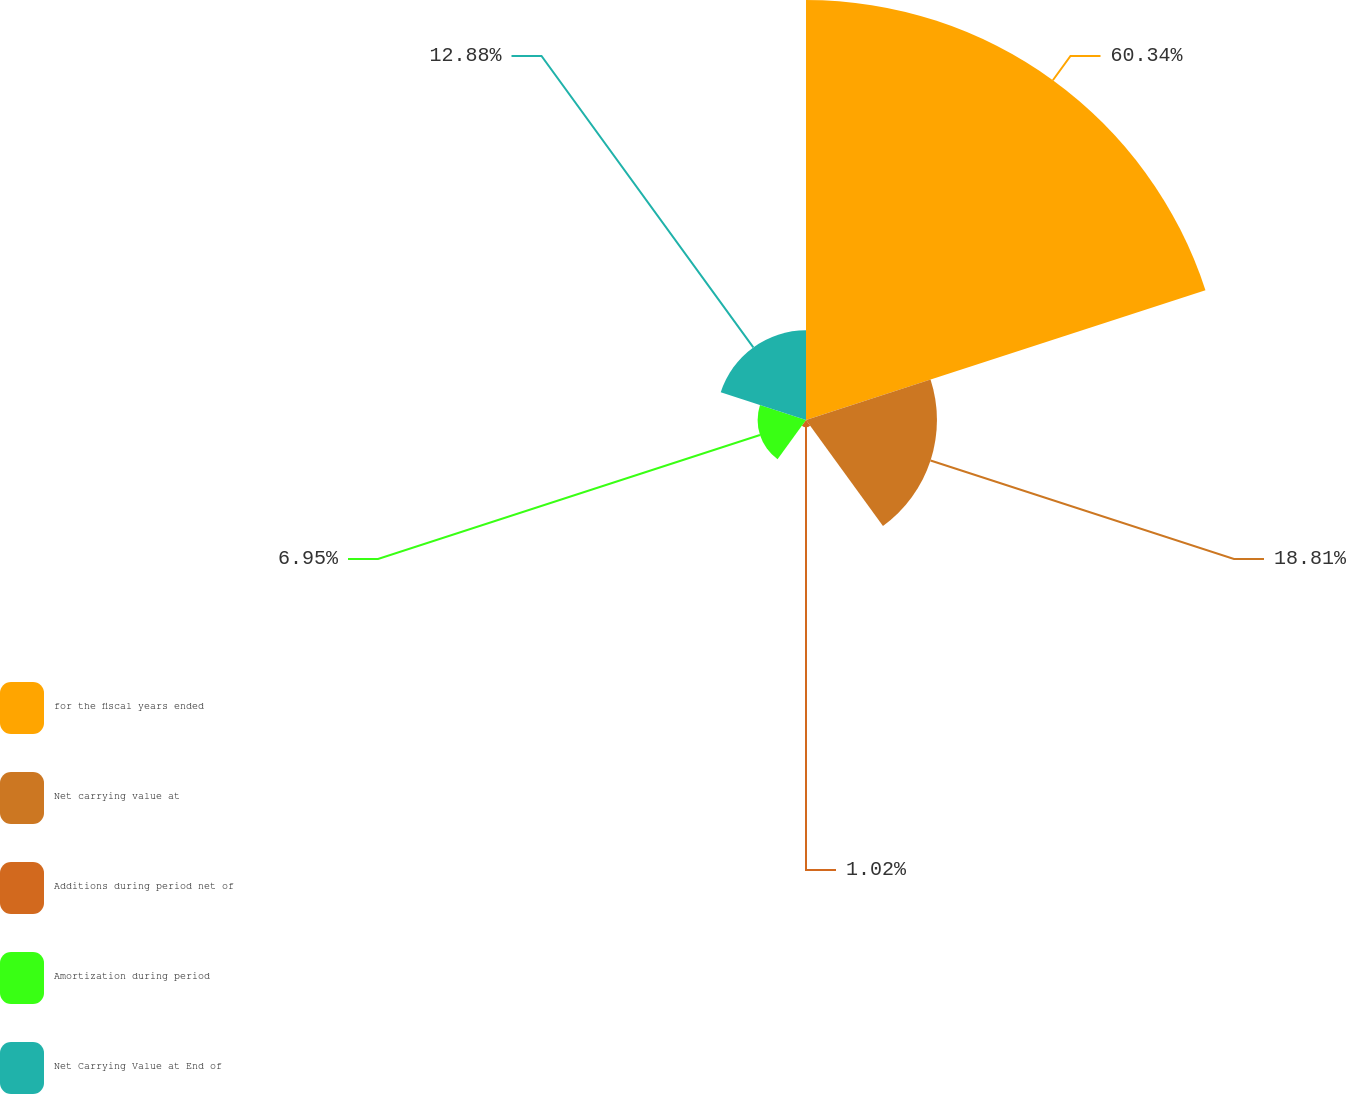<chart> <loc_0><loc_0><loc_500><loc_500><pie_chart><fcel>for the fiscal years ended<fcel>Net carrying value at<fcel>Additions during period net of<fcel>Amortization during period<fcel>Net Carrying Value at End of<nl><fcel>60.33%<fcel>18.81%<fcel>1.02%<fcel>6.95%<fcel>12.88%<nl></chart> 